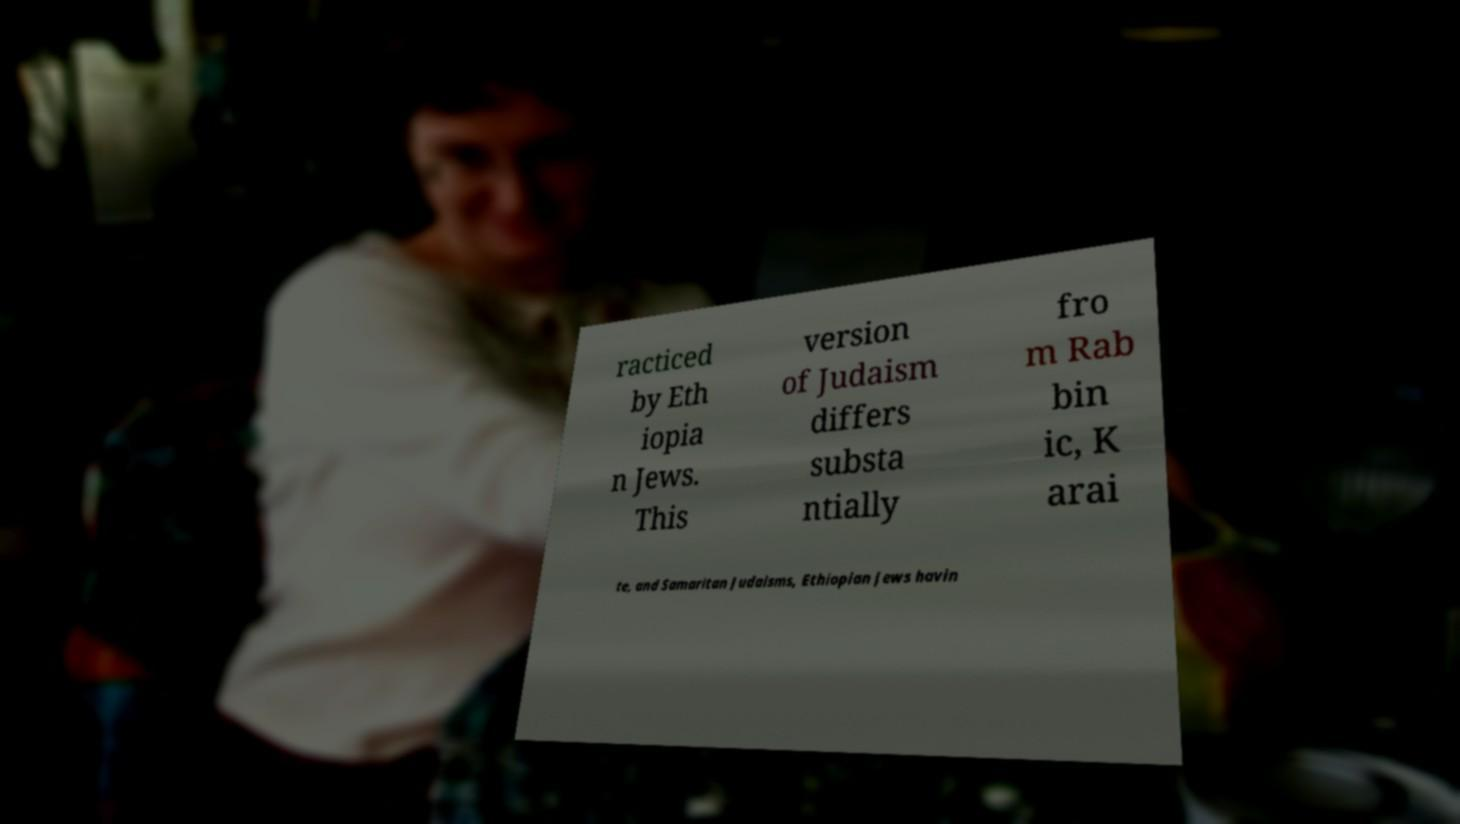Could you assist in decoding the text presented in this image and type it out clearly? racticed by Eth iopia n Jews. This version of Judaism differs substa ntially fro m Rab bin ic, K arai te, and Samaritan Judaisms, Ethiopian Jews havin 